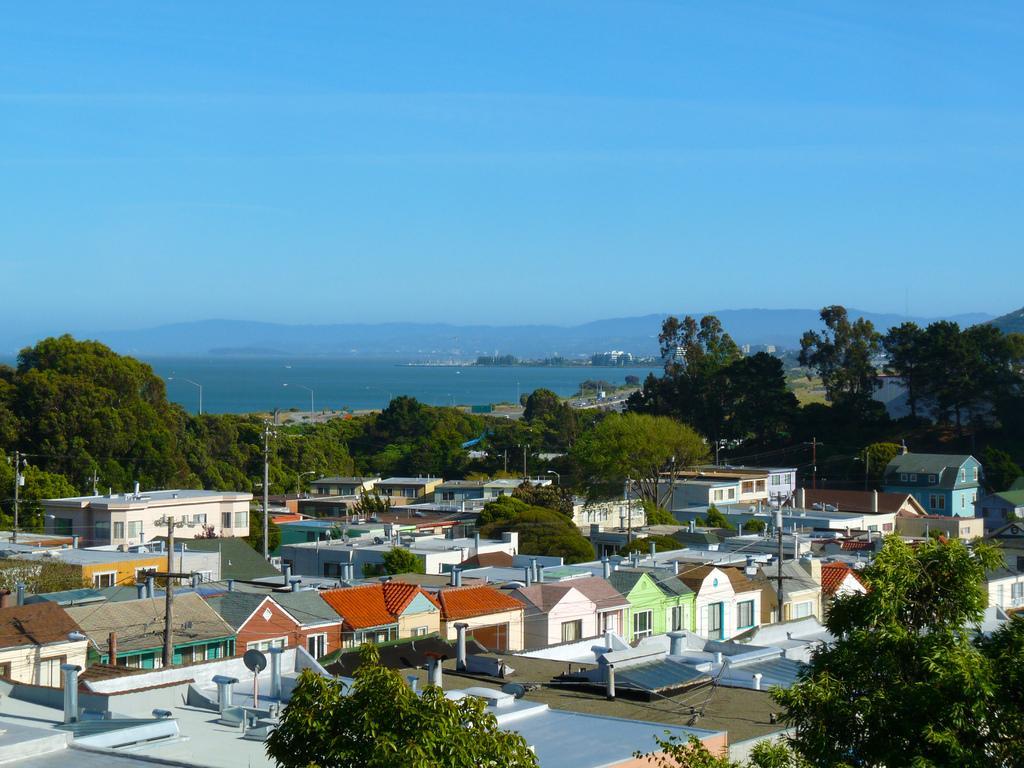How would you summarize this image in a sentence or two? In the foreground of the picture there are houses, trees, current poles, cables and roads. In the center the background there are hills, trees and water. Sky is clear and it is sunny. 